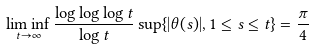<formula> <loc_0><loc_0><loc_500><loc_500>\liminf _ { t \to \infty } \frac { \log \log \log t } { \log t } \sup \{ | \theta ( s ) | , 1 \leq s \leq t \} = \frac { \pi } { 4 }</formula> 